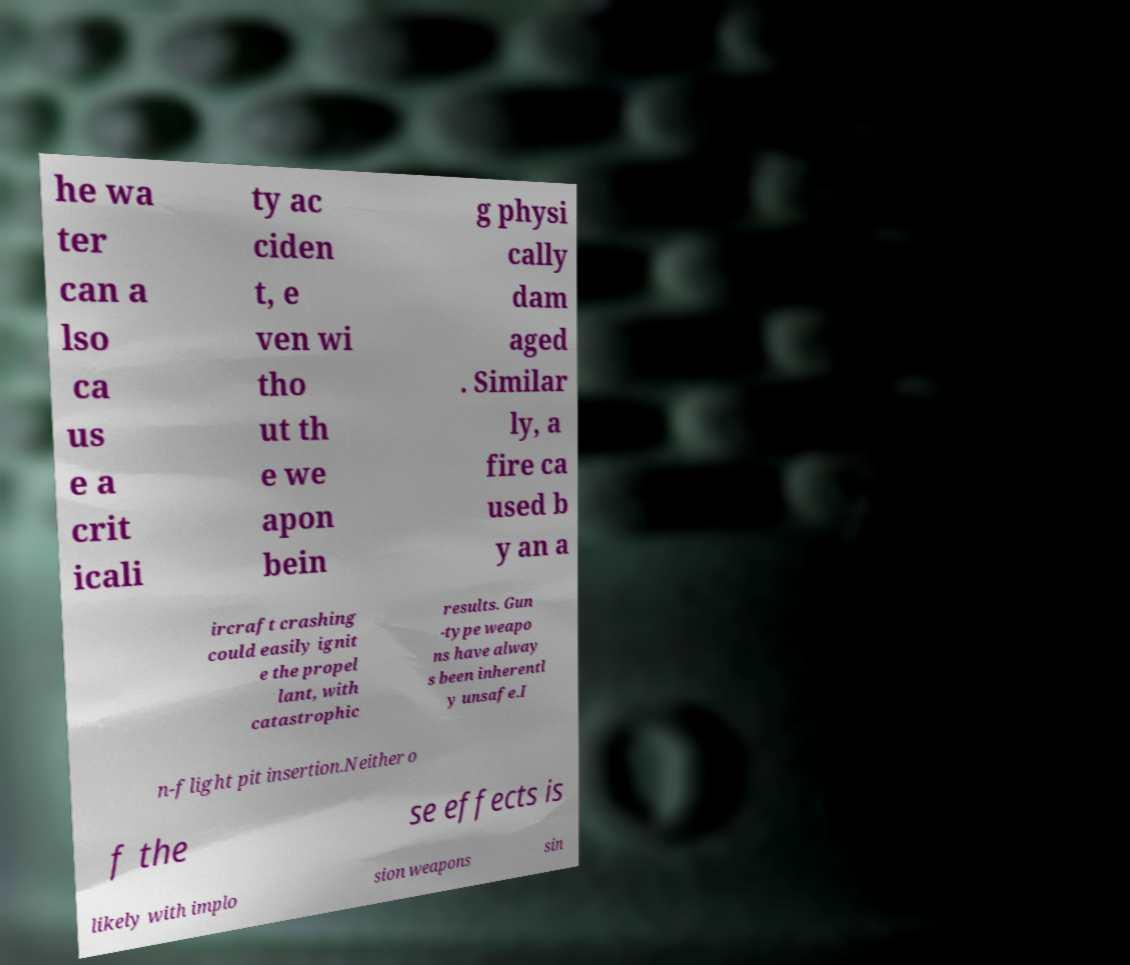Can you accurately transcribe the text from the provided image for me? he wa ter can a lso ca us e a crit icali ty ac ciden t, e ven wi tho ut th e we apon bein g physi cally dam aged . Similar ly, a fire ca used b y an a ircraft crashing could easily ignit e the propel lant, with catastrophic results. Gun -type weapo ns have alway s been inherentl y unsafe.I n-flight pit insertion.Neither o f the se effects is likely with implo sion weapons sin 